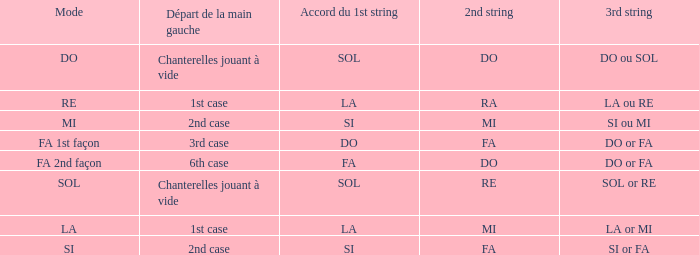For a 1st string of si Accord du and a 2nd string of mi what is the 3rd string? SI ou MI. 